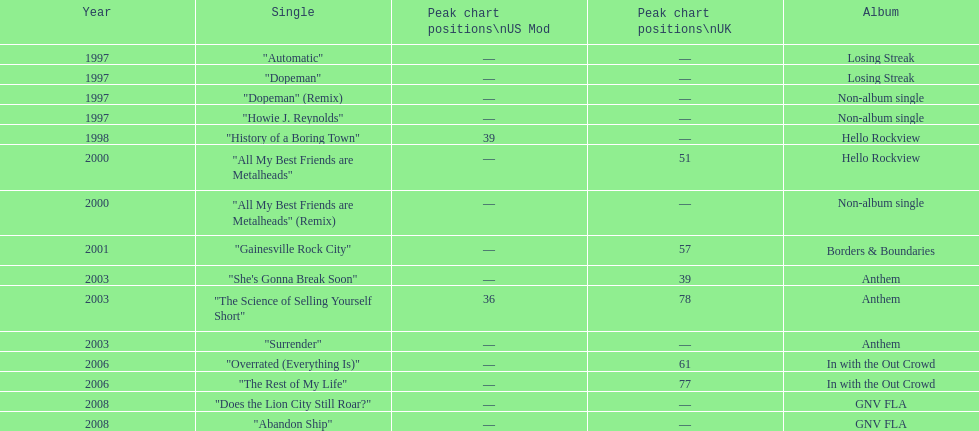Which year witnessed the highest number of single releases? 1997. 